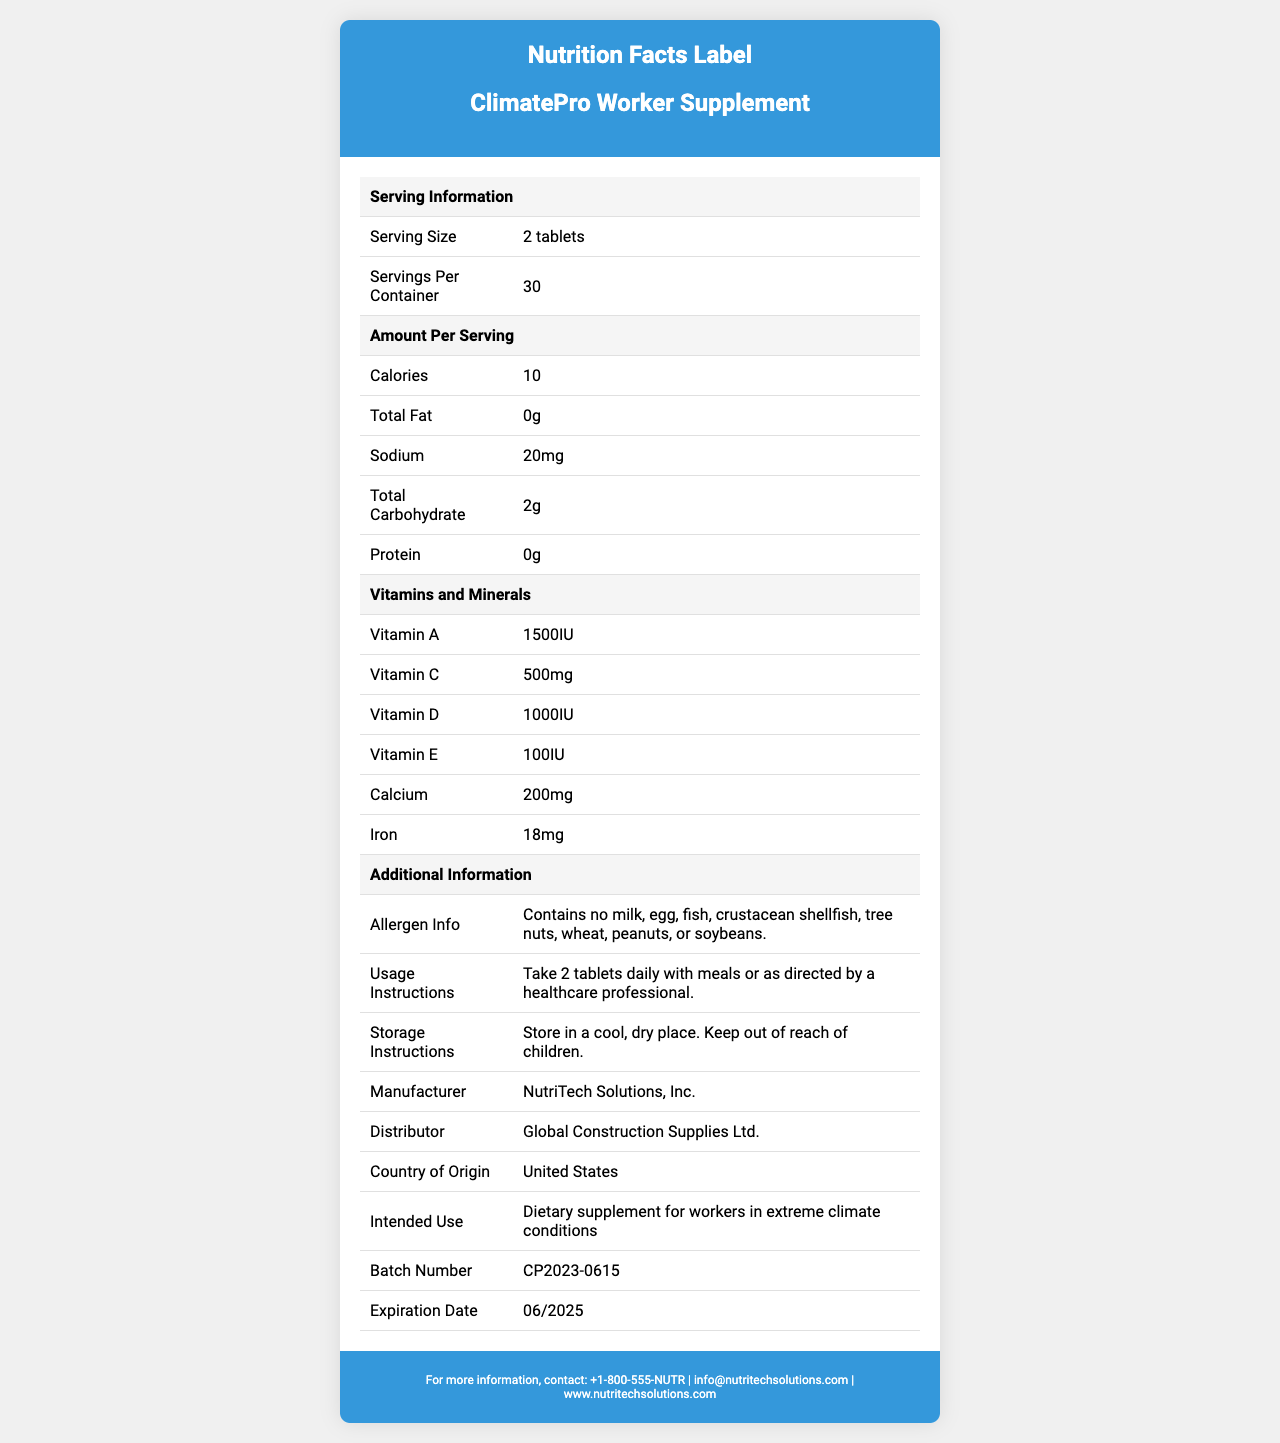what is the serving size of the ClimatePro Worker Supplement? The serving size is listed under 'Serving Information' as "2 tablets."
Answer: 2 tablets how many calories does one serving contain? The number of calories per serving is under 'Amount Per Serving' and is listed as 10.
Answer: 10 who is the manufacturer of this supplement? The manufacturer is listed under the 'Additional Information' section as "NutriTech Solutions, Inc."
Answer: NutriTech Solutions, Inc. what is the expiration date of this supplement? The expiration date is listed under 'Additional Information' as "06/2025."
Answer: 06/2025 how many milligrams of vitamin C are in one serving? The amount of vitamin C is listed under 'Vitamins and Minerals' as "500mg."
Answer: 500mg how many servings are there per container? A. 15 B. 30 C. 60 The 'Serving Information' section lists the 'Servings Per Container' as 30.
Answer: B. 30 which of the following vitamins is included in the highest quantity per serving? A. Vitamin A B. Vitamin C C. Vitamin E D. Vitamin D By comparing the vitamin amounts under 'Vitamins and Minerals', Vitamin C has the highest quantity at 500mg.
Answer: B. Vitamin C is there any iron content in this supplement? The 'Vitamins and Minerals' section lists iron with a quantity of "18mg," confirming its presence.
Answer: Yes does this supplement contain allergens like milk, egg, or soybeans? The 'Allergen Info' section explicitly states that it contains no milk, egg, fish, crustacean shellfish, tree nuts, wheat, peanuts, or soybeans.
Answer: No Summarize the main information provided in the Nutrition Facts Label. The document provides a comprehensive overview of the nutritional content and instructions associated with the 'ClimatePro Worker Supplement,' along with manufacturer, distributor, allergen info, and intended use.
Answer: The Nutrition Facts Label for 'ClimatePro Worker Supplement' details serving size (2 tablets), the number of servings per container (30), calories per serving (10), and nutritional content, including vitamins and minerals. It also includes allergen information (free of common allergens), usage instructions, storage instructions, manufacturer details (NutriTech Solutions, Inc.), distributor details (Global Construction Supplies Ltd.), and regulatory compliance. The supplement is intended for workers in extreme climate conditions. what are the ingredients in the electrolyte blend? The electrolyte blend ingredients are listed under their specific section in the document.
Answer: sodium citrate, potassium chloride, magnesium citrate what is the purpose of this supplement according to the document? The intended use is specified under 'Additional Information' as "Dietary supplement for workers in extreme climate conditions."
Answer: Dietary supplement for workers in extreme climate conditions what climate conditions are specified for the intended use of this supplement? The specific climate conditions are listed under 'Additional Information' as "High temperature environments (above 35°C/95°F), High humidity environments (above 70% relative humidity), Arid desert conditions, High-altitude worksites (above 2,500 meters/8,200 feet)."
Answer: High temperature environments, high humidity environments, arid desert conditions, high-altitude worksites is this supplement FDA cGMP Compliant? The compliance information listed in the document includes "FDA cGMP Compliant," confirming it's FDA cGMP Compliant.
Answer: Yes can I find details on the cost of this supplement in the document? The document does not provide any information about the cost or pricing of the supplement.
Answer: Cannot be determined 